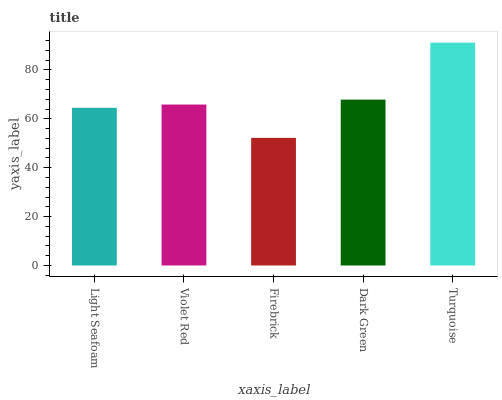Is Violet Red the minimum?
Answer yes or no. No. Is Violet Red the maximum?
Answer yes or no. No. Is Violet Red greater than Light Seafoam?
Answer yes or no. Yes. Is Light Seafoam less than Violet Red?
Answer yes or no. Yes. Is Light Seafoam greater than Violet Red?
Answer yes or no. No. Is Violet Red less than Light Seafoam?
Answer yes or no. No. Is Violet Red the high median?
Answer yes or no. Yes. Is Violet Red the low median?
Answer yes or no. Yes. Is Firebrick the high median?
Answer yes or no. No. Is Firebrick the low median?
Answer yes or no. No. 